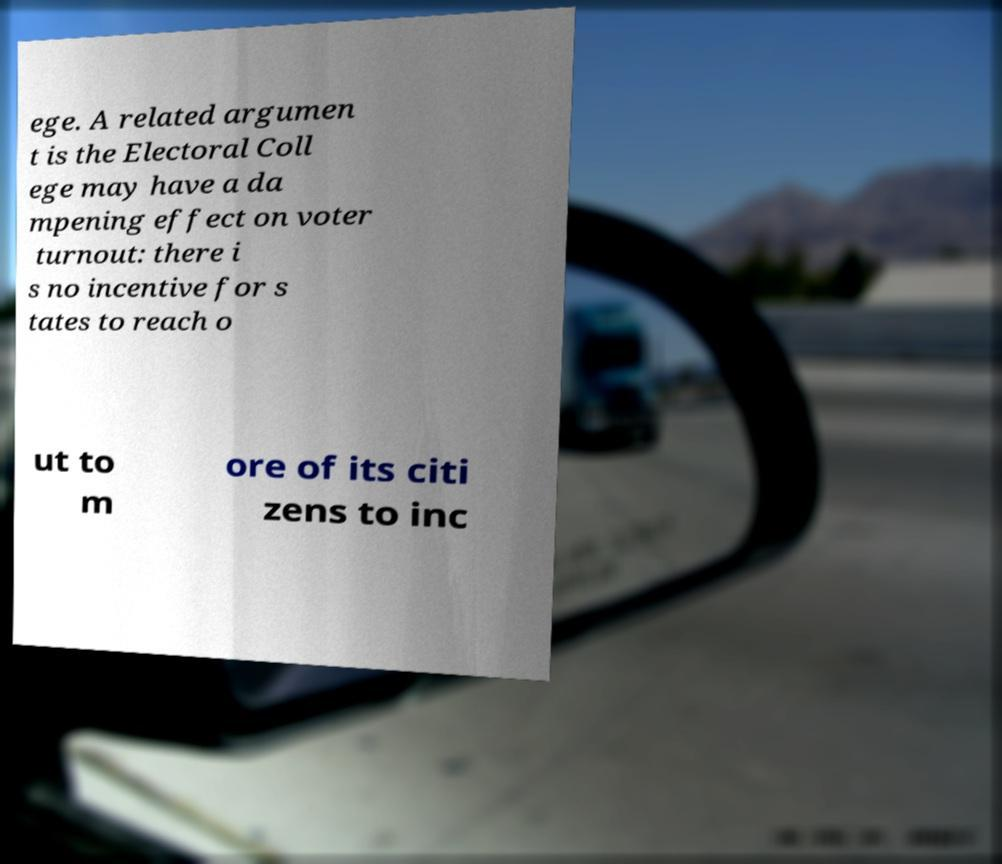Can you accurately transcribe the text from the provided image for me? ege. A related argumen t is the Electoral Coll ege may have a da mpening effect on voter turnout: there i s no incentive for s tates to reach o ut to m ore of its citi zens to inc 